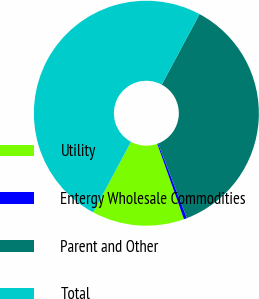Convert chart. <chart><loc_0><loc_0><loc_500><loc_500><pie_chart><fcel>Utility<fcel>Entergy Wholesale Commodities<fcel>Parent and Other<fcel>Total<nl><fcel>13.27%<fcel>0.44%<fcel>36.29%<fcel>50.0%<nl></chart> 